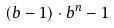Convert formula to latex. <formula><loc_0><loc_0><loc_500><loc_500>( b - 1 ) \cdot b ^ { n } - 1</formula> 